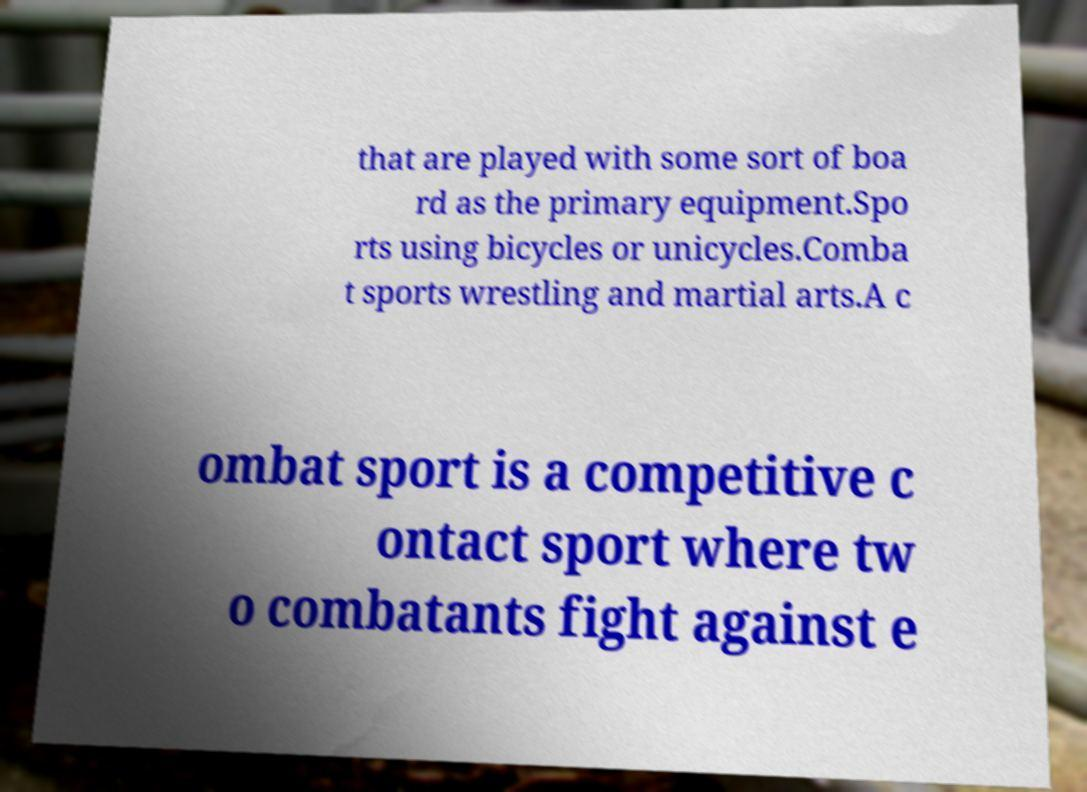For documentation purposes, I need the text within this image transcribed. Could you provide that? that are played with some sort of boa rd as the primary equipment.Spo rts using bicycles or unicycles.Comba t sports wrestling and martial arts.A c ombat sport is a competitive c ontact sport where tw o combatants fight against e 